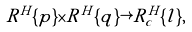Convert formula to latex. <formula><loc_0><loc_0><loc_500><loc_500>R ^ { H } \{ p \} \times R ^ { H } \{ q \} \rightarrow R ^ { H } _ { c } \{ l \} ,</formula> 